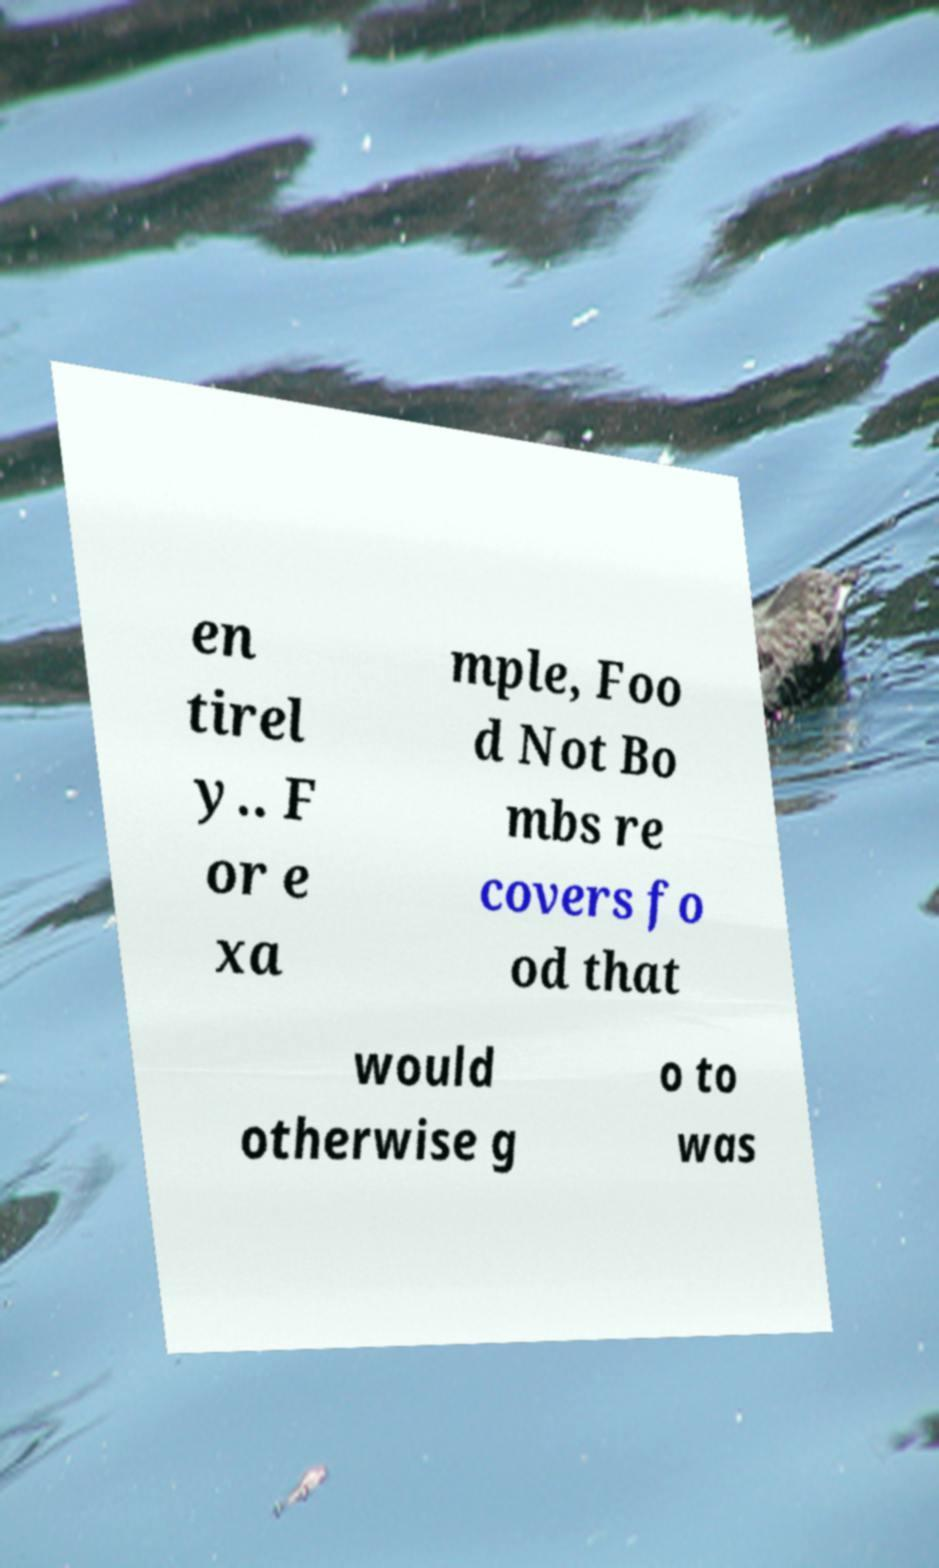Please identify and transcribe the text found in this image. en tirel y.. F or e xa mple, Foo d Not Bo mbs re covers fo od that would otherwise g o to was 